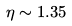Convert formula to latex. <formula><loc_0><loc_0><loc_500><loc_500>\eta \sim 1 . 3 5</formula> 